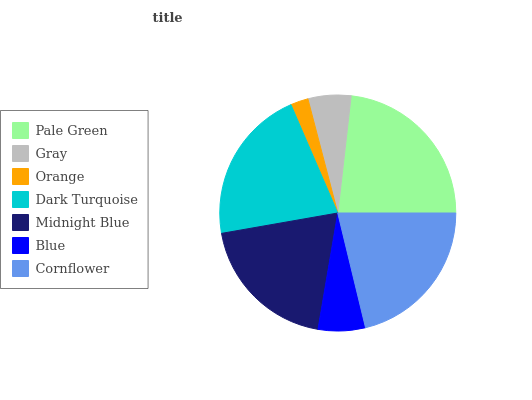Is Orange the minimum?
Answer yes or no. Yes. Is Pale Green the maximum?
Answer yes or no. Yes. Is Gray the minimum?
Answer yes or no. No. Is Gray the maximum?
Answer yes or no. No. Is Pale Green greater than Gray?
Answer yes or no. Yes. Is Gray less than Pale Green?
Answer yes or no. Yes. Is Gray greater than Pale Green?
Answer yes or no. No. Is Pale Green less than Gray?
Answer yes or no. No. Is Midnight Blue the high median?
Answer yes or no. Yes. Is Midnight Blue the low median?
Answer yes or no. Yes. Is Blue the high median?
Answer yes or no. No. Is Pale Green the low median?
Answer yes or no. No. 